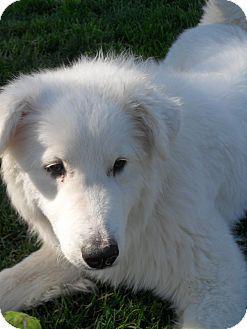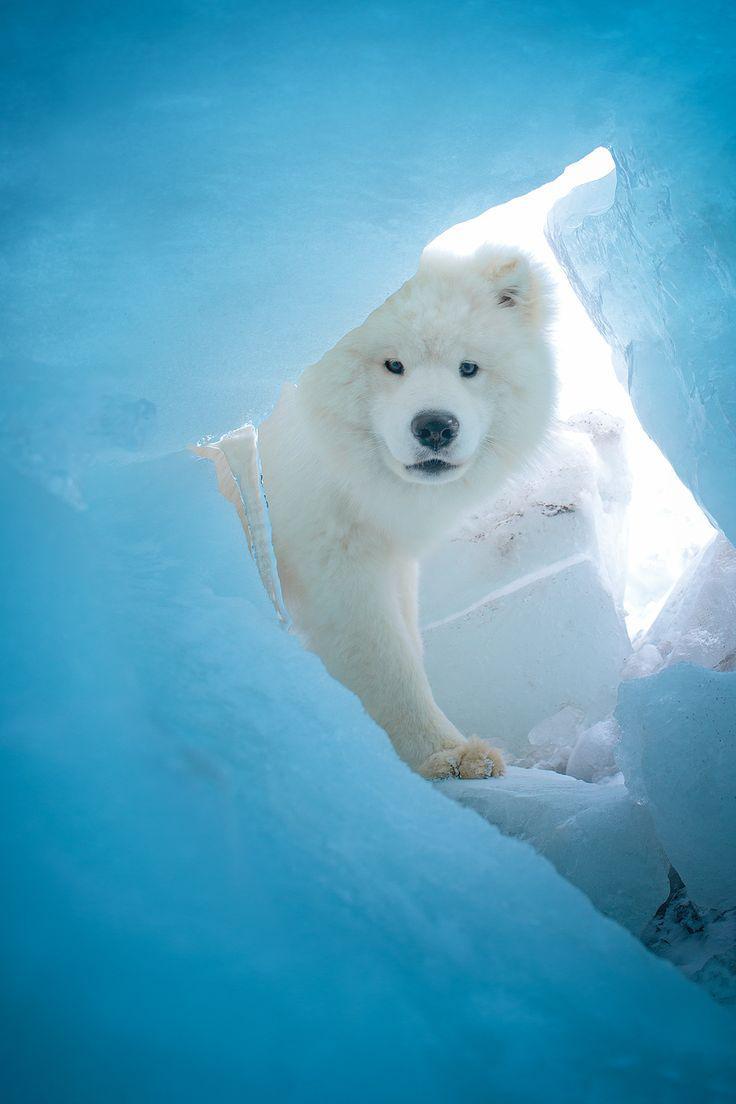The first image is the image on the left, the second image is the image on the right. Examine the images to the left and right. Is the description "One of the images shows a dog in snow." accurate? Answer yes or no. Yes. The first image is the image on the left, the second image is the image on the right. Analyze the images presented: Is the assertion "An image shows one white dog in an arctic-type frozen scene." valid? Answer yes or no. Yes. 